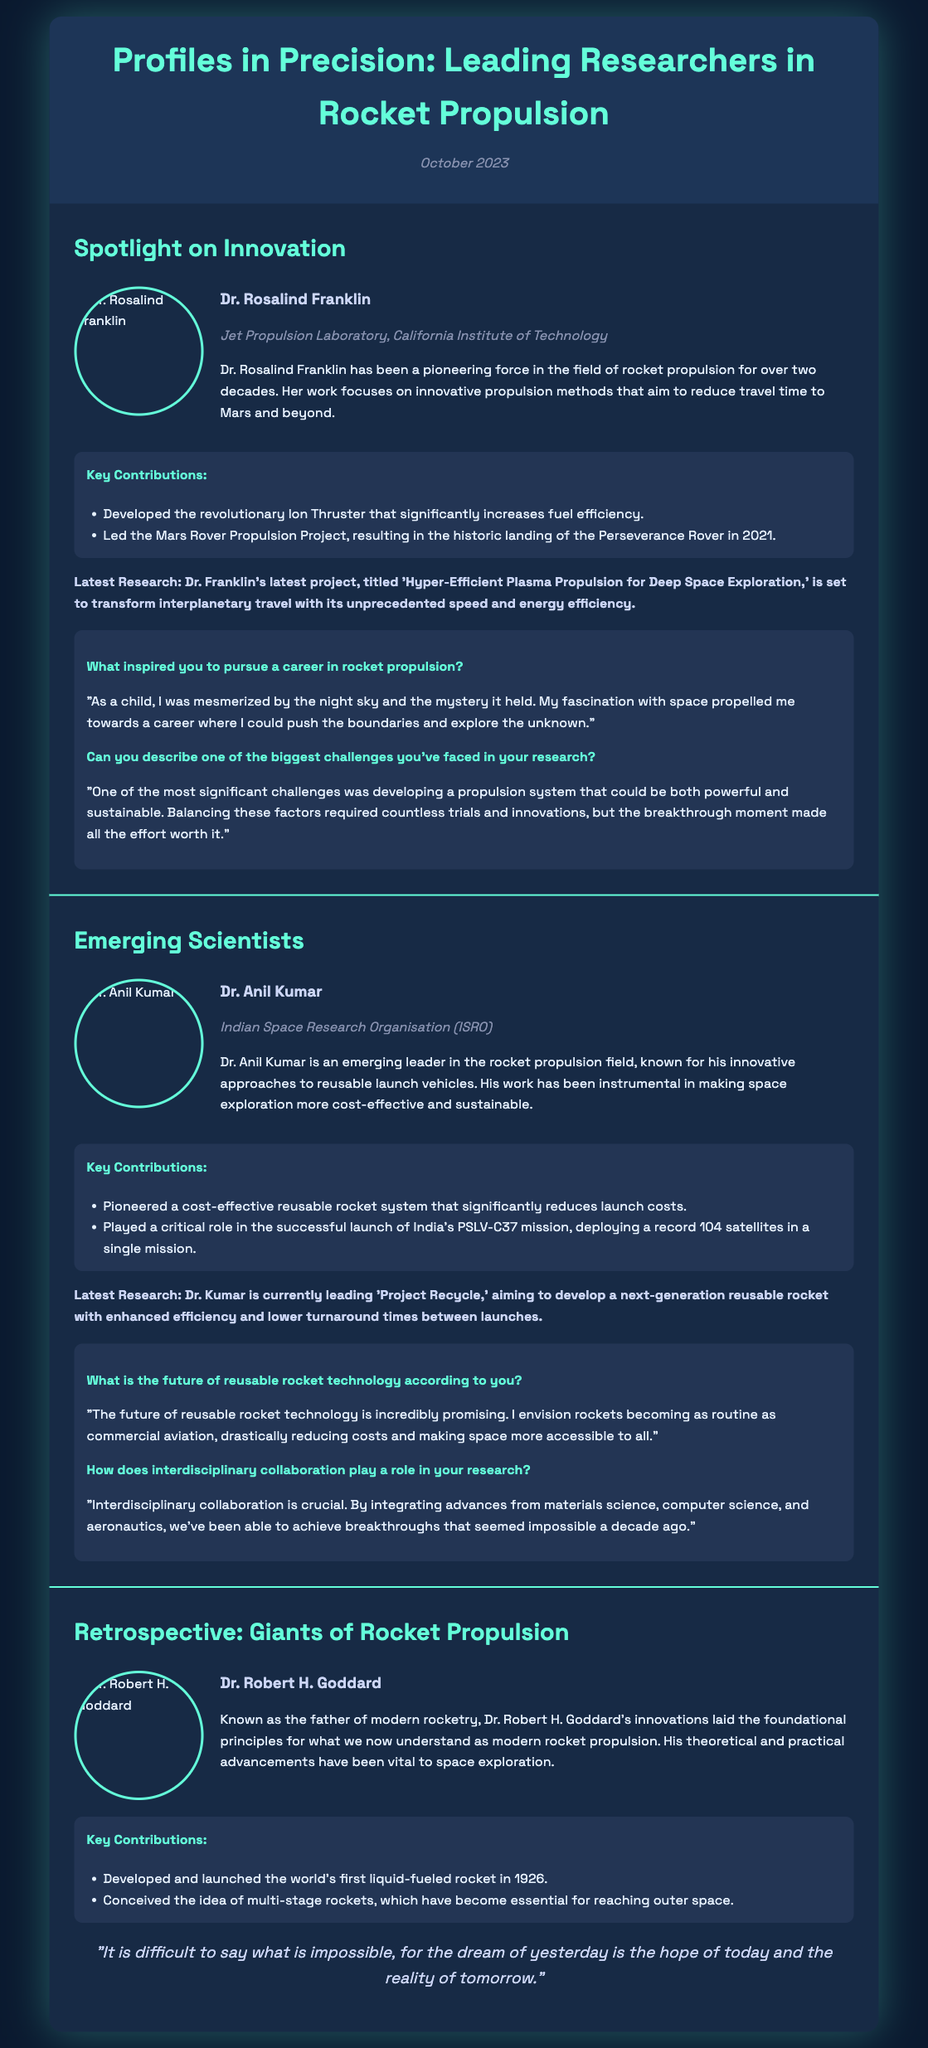What is the title of the latest issue? The title of the latest issue is prominently displayed at the top of the document.
Answer: Profiles in Precision: Leading Researchers in Rocket Propulsion Who is featured as a researcher at the Jet Propulsion Laboratory? The document lists the names of researchers, and one of them is specifically associated with the Jet Propulsion Laboratory.
Answer: Dr. Rosalind Franklin What recent project is Dr. Anil Kumar currently leading? The document includes a description of Dr. Kumar's latest research project, which is mentioned in the section about emerging scientists.
Answer: Project Recycle What groundbreaking system did Dr. Rosalind Franklin develop? The document outlines Dr. Franklin's key contributions to rocket propulsion, including an innovative propulsion system.
Answer: Ion Thruster When did Dr. Robert H. Goddard launch the world's first liquid-fueled rocket? The document states the historical achievements of Dr. Goddard, including the date of the rocket launch.
Answer: 1926 How many satellites were launched in the PSLV-C37 mission? The document mentions the specific number of satellites involved in the successful mission.
Answer: 104 What is the color scheme of the Playbill document? The overall style and color scheme are described throughout the document, indicating a consistent theme.
Answer: Dark blue and teal What is the primary focus of Dr. Anil Kumar’s research? The document provides a summary of Dr. Kumar's research focus, highlighting its main objective.
Answer: Reusable launch vehicles 